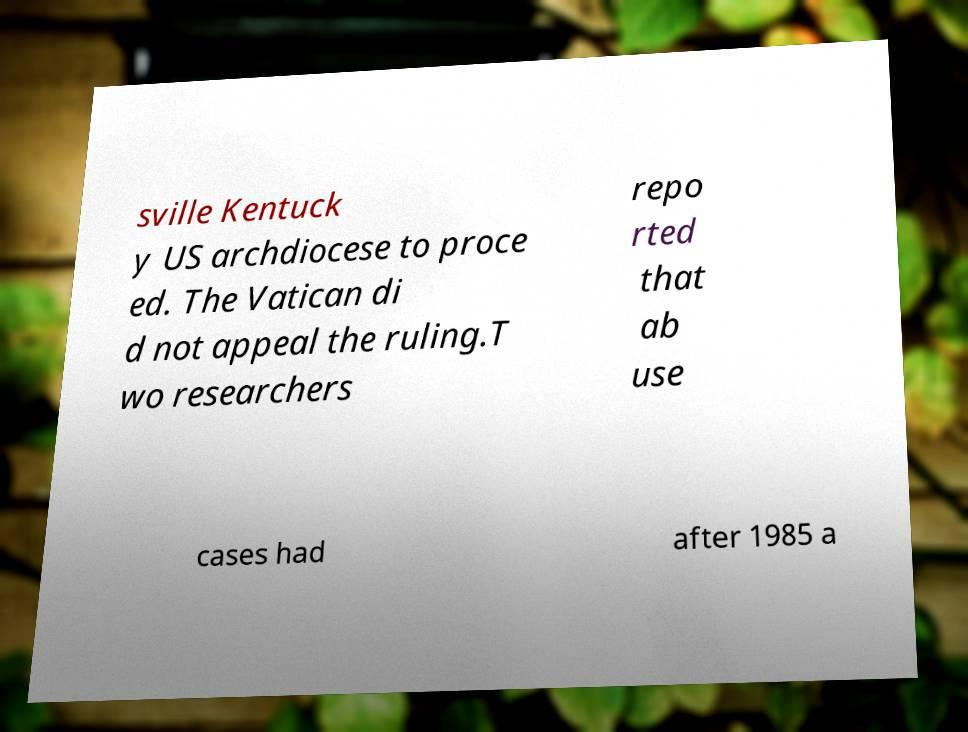I need the written content from this picture converted into text. Can you do that? sville Kentuck y US archdiocese to proce ed. The Vatican di d not appeal the ruling.T wo researchers repo rted that ab use cases had after 1985 a 